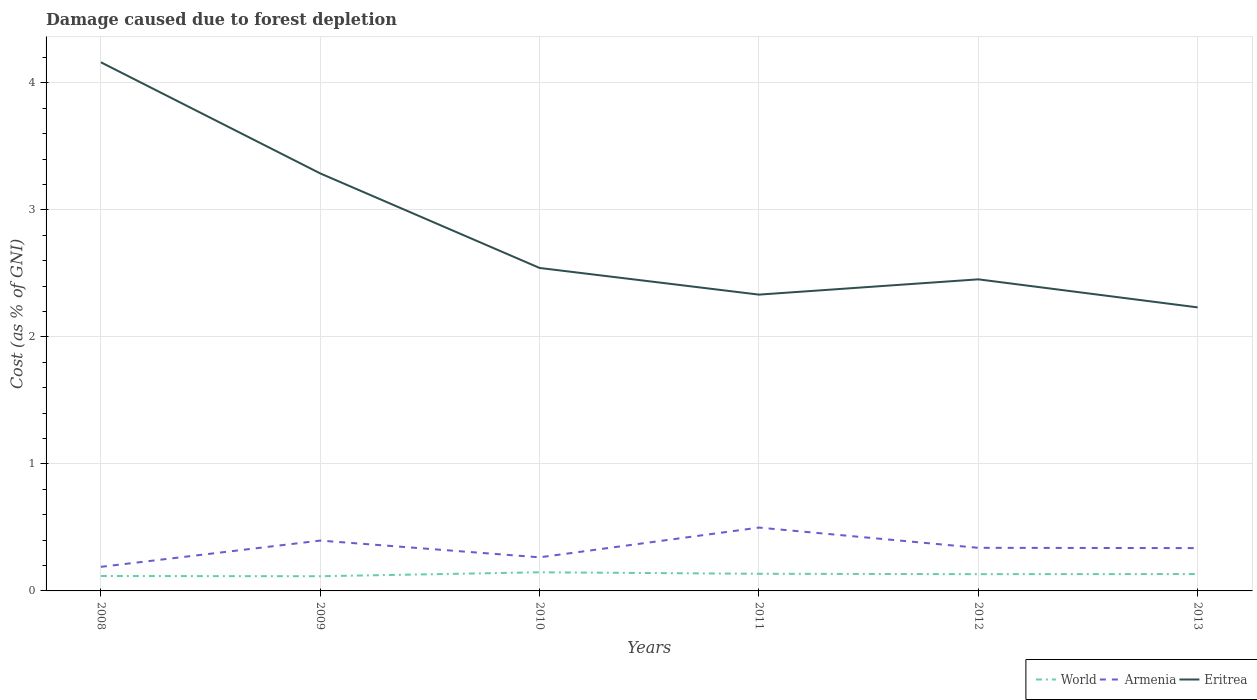How many different coloured lines are there?
Provide a succinct answer. 3. Is the number of lines equal to the number of legend labels?
Provide a short and direct response. Yes. Across all years, what is the maximum cost of damage caused due to forest depletion in World?
Keep it short and to the point. 0.12. What is the total cost of damage caused due to forest depletion in Eritrea in the graph?
Offer a very short reply. -0.12. What is the difference between the highest and the second highest cost of damage caused due to forest depletion in World?
Ensure brevity in your answer.  0.03. What is the difference between two consecutive major ticks on the Y-axis?
Provide a succinct answer. 1. Does the graph contain any zero values?
Ensure brevity in your answer.  No. Where does the legend appear in the graph?
Provide a succinct answer. Bottom right. How many legend labels are there?
Your response must be concise. 3. What is the title of the graph?
Keep it short and to the point. Damage caused due to forest depletion. Does "Greenland" appear as one of the legend labels in the graph?
Provide a succinct answer. No. What is the label or title of the Y-axis?
Keep it short and to the point. Cost (as % of GNI). What is the Cost (as % of GNI) of World in 2008?
Provide a short and direct response. 0.12. What is the Cost (as % of GNI) in Armenia in 2008?
Keep it short and to the point. 0.19. What is the Cost (as % of GNI) in Eritrea in 2008?
Keep it short and to the point. 4.16. What is the Cost (as % of GNI) in World in 2009?
Offer a terse response. 0.12. What is the Cost (as % of GNI) in Armenia in 2009?
Your answer should be compact. 0.4. What is the Cost (as % of GNI) in Eritrea in 2009?
Make the answer very short. 3.29. What is the Cost (as % of GNI) in World in 2010?
Provide a short and direct response. 0.15. What is the Cost (as % of GNI) in Armenia in 2010?
Your answer should be compact. 0.26. What is the Cost (as % of GNI) of Eritrea in 2010?
Make the answer very short. 2.54. What is the Cost (as % of GNI) of World in 2011?
Give a very brief answer. 0.13. What is the Cost (as % of GNI) of Armenia in 2011?
Provide a succinct answer. 0.5. What is the Cost (as % of GNI) of Eritrea in 2011?
Your response must be concise. 2.33. What is the Cost (as % of GNI) in World in 2012?
Offer a terse response. 0.13. What is the Cost (as % of GNI) in Armenia in 2012?
Offer a terse response. 0.34. What is the Cost (as % of GNI) of Eritrea in 2012?
Offer a very short reply. 2.45. What is the Cost (as % of GNI) in World in 2013?
Give a very brief answer. 0.13. What is the Cost (as % of GNI) of Armenia in 2013?
Give a very brief answer. 0.34. What is the Cost (as % of GNI) in Eritrea in 2013?
Ensure brevity in your answer.  2.23. Across all years, what is the maximum Cost (as % of GNI) of World?
Give a very brief answer. 0.15. Across all years, what is the maximum Cost (as % of GNI) in Armenia?
Provide a short and direct response. 0.5. Across all years, what is the maximum Cost (as % of GNI) in Eritrea?
Offer a very short reply. 4.16. Across all years, what is the minimum Cost (as % of GNI) in World?
Offer a terse response. 0.12. Across all years, what is the minimum Cost (as % of GNI) in Armenia?
Offer a very short reply. 0.19. Across all years, what is the minimum Cost (as % of GNI) in Eritrea?
Keep it short and to the point. 2.23. What is the total Cost (as % of GNI) in World in the graph?
Your response must be concise. 0.78. What is the total Cost (as % of GNI) of Armenia in the graph?
Make the answer very short. 2.03. What is the total Cost (as % of GNI) of Eritrea in the graph?
Offer a very short reply. 17.01. What is the difference between the Cost (as % of GNI) of World in 2008 and that in 2009?
Your answer should be compact. 0. What is the difference between the Cost (as % of GNI) of Armenia in 2008 and that in 2009?
Ensure brevity in your answer.  -0.21. What is the difference between the Cost (as % of GNI) of Eritrea in 2008 and that in 2009?
Make the answer very short. 0.87. What is the difference between the Cost (as % of GNI) of World in 2008 and that in 2010?
Your response must be concise. -0.03. What is the difference between the Cost (as % of GNI) of Armenia in 2008 and that in 2010?
Your answer should be very brief. -0.07. What is the difference between the Cost (as % of GNI) of Eritrea in 2008 and that in 2010?
Provide a short and direct response. 1.62. What is the difference between the Cost (as % of GNI) of World in 2008 and that in 2011?
Your answer should be very brief. -0.02. What is the difference between the Cost (as % of GNI) in Armenia in 2008 and that in 2011?
Your response must be concise. -0.31. What is the difference between the Cost (as % of GNI) in Eritrea in 2008 and that in 2011?
Provide a succinct answer. 1.83. What is the difference between the Cost (as % of GNI) in World in 2008 and that in 2012?
Give a very brief answer. -0.01. What is the difference between the Cost (as % of GNI) of Armenia in 2008 and that in 2012?
Offer a terse response. -0.15. What is the difference between the Cost (as % of GNI) of Eritrea in 2008 and that in 2012?
Offer a terse response. 1.71. What is the difference between the Cost (as % of GNI) of World in 2008 and that in 2013?
Your response must be concise. -0.02. What is the difference between the Cost (as % of GNI) in Armenia in 2008 and that in 2013?
Offer a terse response. -0.15. What is the difference between the Cost (as % of GNI) in Eritrea in 2008 and that in 2013?
Provide a short and direct response. 1.93. What is the difference between the Cost (as % of GNI) in World in 2009 and that in 2010?
Your answer should be compact. -0.03. What is the difference between the Cost (as % of GNI) in Armenia in 2009 and that in 2010?
Make the answer very short. 0.13. What is the difference between the Cost (as % of GNI) of Eritrea in 2009 and that in 2010?
Make the answer very short. 0.74. What is the difference between the Cost (as % of GNI) in World in 2009 and that in 2011?
Keep it short and to the point. -0.02. What is the difference between the Cost (as % of GNI) in Armenia in 2009 and that in 2011?
Provide a succinct answer. -0.1. What is the difference between the Cost (as % of GNI) of Eritrea in 2009 and that in 2011?
Make the answer very short. 0.95. What is the difference between the Cost (as % of GNI) of World in 2009 and that in 2012?
Give a very brief answer. -0.02. What is the difference between the Cost (as % of GNI) of Armenia in 2009 and that in 2012?
Ensure brevity in your answer.  0.06. What is the difference between the Cost (as % of GNI) in Eritrea in 2009 and that in 2012?
Your answer should be very brief. 0.83. What is the difference between the Cost (as % of GNI) of World in 2009 and that in 2013?
Your answer should be very brief. -0.02. What is the difference between the Cost (as % of GNI) in Armenia in 2009 and that in 2013?
Provide a short and direct response. 0.06. What is the difference between the Cost (as % of GNI) in Eritrea in 2009 and that in 2013?
Provide a short and direct response. 1.05. What is the difference between the Cost (as % of GNI) of World in 2010 and that in 2011?
Your answer should be compact. 0.01. What is the difference between the Cost (as % of GNI) in Armenia in 2010 and that in 2011?
Offer a terse response. -0.23. What is the difference between the Cost (as % of GNI) in Eritrea in 2010 and that in 2011?
Your response must be concise. 0.21. What is the difference between the Cost (as % of GNI) in World in 2010 and that in 2012?
Your response must be concise. 0.01. What is the difference between the Cost (as % of GNI) in Armenia in 2010 and that in 2012?
Make the answer very short. -0.07. What is the difference between the Cost (as % of GNI) of Eritrea in 2010 and that in 2012?
Make the answer very short. 0.09. What is the difference between the Cost (as % of GNI) of World in 2010 and that in 2013?
Give a very brief answer. 0.01. What is the difference between the Cost (as % of GNI) in Armenia in 2010 and that in 2013?
Provide a short and direct response. -0.07. What is the difference between the Cost (as % of GNI) of Eritrea in 2010 and that in 2013?
Offer a very short reply. 0.31. What is the difference between the Cost (as % of GNI) of World in 2011 and that in 2012?
Offer a very short reply. 0. What is the difference between the Cost (as % of GNI) in Armenia in 2011 and that in 2012?
Your response must be concise. 0.16. What is the difference between the Cost (as % of GNI) in Eritrea in 2011 and that in 2012?
Your answer should be very brief. -0.12. What is the difference between the Cost (as % of GNI) of World in 2011 and that in 2013?
Offer a terse response. 0. What is the difference between the Cost (as % of GNI) in Armenia in 2011 and that in 2013?
Offer a terse response. 0.16. What is the difference between the Cost (as % of GNI) of Eritrea in 2011 and that in 2013?
Provide a short and direct response. 0.1. What is the difference between the Cost (as % of GNI) in World in 2012 and that in 2013?
Your response must be concise. -0. What is the difference between the Cost (as % of GNI) in Armenia in 2012 and that in 2013?
Your response must be concise. 0. What is the difference between the Cost (as % of GNI) of Eritrea in 2012 and that in 2013?
Provide a short and direct response. 0.22. What is the difference between the Cost (as % of GNI) in World in 2008 and the Cost (as % of GNI) in Armenia in 2009?
Offer a terse response. -0.28. What is the difference between the Cost (as % of GNI) in World in 2008 and the Cost (as % of GNI) in Eritrea in 2009?
Make the answer very short. -3.17. What is the difference between the Cost (as % of GNI) in Armenia in 2008 and the Cost (as % of GNI) in Eritrea in 2009?
Give a very brief answer. -3.1. What is the difference between the Cost (as % of GNI) of World in 2008 and the Cost (as % of GNI) of Armenia in 2010?
Provide a short and direct response. -0.15. What is the difference between the Cost (as % of GNI) of World in 2008 and the Cost (as % of GNI) of Eritrea in 2010?
Keep it short and to the point. -2.43. What is the difference between the Cost (as % of GNI) in Armenia in 2008 and the Cost (as % of GNI) in Eritrea in 2010?
Keep it short and to the point. -2.35. What is the difference between the Cost (as % of GNI) in World in 2008 and the Cost (as % of GNI) in Armenia in 2011?
Offer a terse response. -0.38. What is the difference between the Cost (as % of GNI) of World in 2008 and the Cost (as % of GNI) of Eritrea in 2011?
Your answer should be very brief. -2.22. What is the difference between the Cost (as % of GNI) in Armenia in 2008 and the Cost (as % of GNI) in Eritrea in 2011?
Provide a succinct answer. -2.14. What is the difference between the Cost (as % of GNI) in World in 2008 and the Cost (as % of GNI) in Armenia in 2012?
Offer a very short reply. -0.22. What is the difference between the Cost (as % of GNI) in World in 2008 and the Cost (as % of GNI) in Eritrea in 2012?
Provide a succinct answer. -2.34. What is the difference between the Cost (as % of GNI) of Armenia in 2008 and the Cost (as % of GNI) of Eritrea in 2012?
Your answer should be compact. -2.26. What is the difference between the Cost (as % of GNI) in World in 2008 and the Cost (as % of GNI) in Armenia in 2013?
Make the answer very short. -0.22. What is the difference between the Cost (as % of GNI) of World in 2008 and the Cost (as % of GNI) of Eritrea in 2013?
Provide a short and direct response. -2.11. What is the difference between the Cost (as % of GNI) of Armenia in 2008 and the Cost (as % of GNI) of Eritrea in 2013?
Ensure brevity in your answer.  -2.04. What is the difference between the Cost (as % of GNI) of World in 2009 and the Cost (as % of GNI) of Armenia in 2010?
Offer a terse response. -0.15. What is the difference between the Cost (as % of GNI) of World in 2009 and the Cost (as % of GNI) of Eritrea in 2010?
Keep it short and to the point. -2.43. What is the difference between the Cost (as % of GNI) of Armenia in 2009 and the Cost (as % of GNI) of Eritrea in 2010?
Provide a succinct answer. -2.15. What is the difference between the Cost (as % of GNI) in World in 2009 and the Cost (as % of GNI) in Armenia in 2011?
Your answer should be compact. -0.38. What is the difference between the Cost (as % of GNI) of World in 2009 and the Cost (as % of GNI) of Eritrea in 2011?
Your response must be concise. -2.22. What is the difference between the Cost (as % of GNI) of Armenia in 2009 and the Cost (as % of GNI) of Eritrea in 2011?
Provide a short and direct response. -1.94. What is the difference between the Cost (as % of GNI) of World in 2009 and the Cost (as % of GNI) of Armenia in 2012?
Ensure brevity in your answer.  -0.22. What is the difference between the Cost (as % of GNI) in World in 2009 and the Cost (as % of GNI) in Eritrea in 2012?
Keep it short and to the point. -2.34. What is the difference between the Cost (as % of GNI) in Armenia in 2009 and the Cost (as % of GNI) in Eritrea in 2012?
Your answer should be compact. -2.06. What is the difference between the Cost (as % of GNI) in World in 2009 and the Cost (as % of GNI) in Armenia in 2013?
Give a very brief answer. -0.22. What is the difference between the Cost (as % of GNI) in World in 2009 and the Cost (as % of GNI) in Eritrea in 2013?
Keep it short and to the point. -2.12. What is the difference between the Cost (as % of GNI) of Armenia in 2009 and the Cost (as % of GNI) of Eritrea in 2013?
Offer a terse response. -1.84. What is the difference between the Cost (as % of GNI) of World in 2010 and the Cost (as % of GNI) of Armenia in 2011?
Provide a succinct answer. -0.35. What is the difference between the Cost (as % of GNI) of World in 2010 and the Cost (as % of GNI) of Eritrea in 2011?
Provide a succinct answer. -2.19. What is the difference between the Cost (as % of GNI) in Armenia in 2010 and the Cost (as % of GNI) in Eritrea in 2011?
Offer a very short reply. -2.07. What is the difference between the Cost (as % of GNI) in World in 2010 and the Cost (as % of GNI) in Armenia in 2012?
Provide a short and direct response. -0.19. What is the difference between the Cost (as % of GNI) of World in 2010 and the Cost (as % of GNI) of Eritrea in 2012?
Provide a short and direct response. -2.31. What is the difference between the Cost (as % of GNI) of Armenia in 2010 and the Cost (as % of GNI) of Eritrea in 2012?
Provide a short and direct response. -2.19. What is the difference between the Cost (as % of GNI) of World in 2010 and the Cost (as % of GNI) of Armenia in 2013?
Provide a succinct answer. -0.19. What is the difference between the Cost (as % of GNI) in World in 2010 and the Cost (as % of GNI) in Eritrea in 2013?
Ensure brevity in your answer.  -2.09. What is the difference between the Cost (as % of GNI) in Armenia in 2010 and the Cost (as % of GNI) in Eritrea in 2013?
Your answer should be compact. -1.97. What is the difference between the Cost (as % of GNI) in World in 2011 and the Cost (as % of GNI) in Armenia in 2012?
Make the answer very short. -0.2. What is the difference between the Cost (as % of GNI) of World in 2011 and the Cost (as % of GNI) of Eritrea in 2012?
Your answer should be compact. -2.32. What is the difference between the Cost (as % of GNI) in Armenia in 2011 and the Cost (as % of GNI) in Eritrea in 2012?
Your answer should be compact. -1.95. What is the difference between the Cost (as % of GNI) of World in 2011 and the Cost (as % of GNI) of Armenia in 2013?
Your answer should be compact. -0.2. What is the difference between the Cost (as % of GNI) of World in 2011 and the Cost (as % of GNI) of Eritrea in 2013?
Provide a short and direct response. -2.1. What is the difference between the Cost (as % of GNI) in Armenia in 2011 and the Cost (as % of GNI) in Eritrea in 2013?
Make the answer very short. -1.73. What is the difference between the Cost (as % of GNI) of World in 2012 and the Cost (as % of GNI) of Armenia in 2013?
Provide a succinct answer. -0.2. What is the difference between the Cost (as % of GNI) in World in 2012 and the Cost (as % of GNI) in Eritrea in 2013?
Make the answer very short. -2.1. What is the difference between the Cost (as % of GNI) in Armenia in 2012 and the Cost (as % of GNI) in Eritrea in 2013?
Make the answer very short. -1.89. What is the average Cost (as % of GNI) in World per year?
Your response must be concise. 0.13. What is the average Cost (as % of GNI) of Armenia per year?
Your answer should be compact. 0.34. What is the average Cost (as % of GNI) in Eritrea per year?
Provide a succinct answer. 2.83. In the year 2008, what is the difference between the Cost (as % of GNI) of World and Cost (as % of GNI) of Armenia?
Your response must be concise. -0.07. In the year 2008, what is the difference between the Cost (as % of GNI) in World and Cost (as % of GNI) in Eritrea?
Give a very brief answer. -4.04. In the year 2008, what is the difference between the Cost (as % of GNI) in Armenia and Cost (as % of GNI) in Eritrea?
Offer a very short reply. -3.97. In the year 2009, what is the difference between the Cost (as % of GNI) in World and Cost (as % of GNI) in Armenia?
Offer a very short reply. -0.28. In the year 2009, what is the difference between the Cost (as % of GNI) of World and Cost (as % of GNI) of Eritrea?
Keep it short and to the point. -3.17. In the year 2009, what is the difference between the Cost (as % of GNI) in Armenia and Cost (as % of GNI) in Eritrea?
Your response must be concise. -2.89. In the year 2010, what is the difference between the Cost (as % of GNI) in World and Cost (as % of GNI) in Armenia?
Offer a terse response. -0.12. In the year 2010, what is the difference between the Cost (as % of GNI) of World and Cost (as % of GNI) of Eritrea?
Your answer should be very brief. -2.4. In the year 2010, what is the difference between the Cost (as % of GNI) in Armenia and Cost (as % of GNI) in Eritrea?
Offer a terse response. -2.28. In the year 2011, what is the difference between the Cost (as % of GNI) of World and Cost (as % of GNI) of Armenia?
Your answer should be compact. -0.36. In the year 2011, what is the difference between the Cost (as % of GNI) of World and Cost (as % of GNI) of Eritrea?
Provide a short and direct response. -2.2. In the year 2011, what is the difference between the Cost (as % of GNI) in Armenia and Cost (as % of GNI) in Eritrea?
Provide a short and direct response. -1.83. In the year 2012, what is the difference between the Cost (as % of GNI) of World and Cost (as % of GNI) of Armenia?
Your answer should be very brief. -0.21. In the year 2012, what is the difference between the Cost (as % of GNI) of World and Cost (as % of GNI) of Eritrea?
Offer a terse response. -2.32. In the year 2012, what is the difference between the Cost (as % of GNI) in Armenia and Cost (as % of GNI) in Eritrea?
Give a very brief answer. -2.11. In the year 2013, what is the difference between the Cost (as % of GNI) in World and Cost (as % of GNI) in Armenia?
Your answer should be very brief. -0.2. In the year 2013, what is the difference between the Cost (as % of GNI) of World and Cost (as % of GNI) of Eritrea?
Keep it short and to the point. -2.1. In the year 2013, what is the difference between the Cost (as % of GNI) in Armenia and Cost (as % of GNI) in Eritrea?
Your answer should be compact. -1.9. What is the ratio of the Cost (as % of GNI) of Armenia in 2008 to that in 2009?
Your answer should be compact. 0.48. What is the ratio of the Cost (as % of GNI) of Eritrea in 2008 to that in 2009?
Provide a short and direct response. 1.27. What is the ratio of the Cost (as % of GNI) of World in 2008 to that in 2010?
Offer a terse response. 0.8. What is the ratio of the Cost (as % of GNI) of Armenia in 2008 to that in 2010?
Provide a succinct answer. 0.72. What is the ratio of the Cost (as % of GNI) of Eritrea in 2008 to that in 2010?
Keep it short and to the point. 1.64. What is the ratio of the Cost (as % of GNI) of World in 2008 to that in 2011?
Provide a short and direct response. 0.87. What is the ratio of the Cost (as % of GNI) of Armenia in 2008 to that in 2011?
Make the answer very short. 0.38. What is the ratio of the Cost (as % of GNI) in Eritrea in 2008 to that in 2011?
Your answer should be very brief. 1.78. What is the ratio of the Cost (as % of GNI) in World in 2008 to that in 2012?
Provide a short and direct response. 0.89. What is the ratio of the Cost (as % of GNI) of Armenia in 2008 to that in 2012?
Your answer should be very brief. 0.56. What is the ratio of the Cost (as % of GNI) in Eritrea in 2008 to that in 2012?
Provide a succinct answer. 1.7. What is the ratio of the Cost (as % of GNI) in World in 2008 to that in 2013?
Offer a very short reply. 0.88. What is the ratio of the Cost (as % of GNI) in Armenia in 2008 to that in 2013?
Provide a succinct answer. 0.56. What is the ratio of the Cost (as % of GNI) of Eritrea in 2008 to that in 2013?
Your answer should be very brief. 1.86. What is the ratio of the Cost (as % of GNI) of World in 2009 to that in 2010?
Give a very brief answer. 0.79. What is the ratio of the Cost (as % of GNI) of Armenia in 2009 to that in 2010?
Your answer should be very brief. 1.5. What is the ratio of the Cost (as % of GNI) of Eritrea in 2009 to that in 2010?
Give a very brief answer. 1.29. What is the ratio of the Cost (as % of GNI) of World in 2009 to that in 2011?
Your response must be concise. 0.86. What is the ratio of the Cost (as % of GNI) in Armenia in 2009 to that in 2011?
Keep it short and to the point. 0.79. What is the ratio of the Cost (as % of GNI) of Eritrea in 2009 to that in 2011?
Your answer should be very brief. 1.41. What is the ratio of the Cost (as % of GNI) of World in 2009 to that in 2012?
Keep it short and to the point. 0.87. What is the ratio of the Cost (as % of GNI) in Armenia in 2009 to that in 2012?
Make the answer very short. 1.17. What is the ratio of the Cost (as % of GNI) of Eritrea in 2009 to that in 2012?
Give a very brief answer. 1.34. What is the ratio of the Cost (as % of GNI) in World in 2009 to that in 2013?
Offer a very short reply. 0.87. What is the ratio of the Cost (as % of GNI) in Armenia in 2009 to that in 2013?
Keep it short and to the point. 1.18. What is the ratio of the Cost (as % of GNI) in Eritrea in 2009 to that in 2013?
Offer a very short reply. 1.47. What is the ratio of the Cost (as % of GNI) of World in 2010 to that in 2011?
Make the answer very short. 1.09. What is the ratio of the Cost (as % of GNI) of Armenia in 2010 to that in 2011?
Provide a succinct answer. 0.53. What is the ratio of the Cost (as % of GNI) in Eritrea in 2010 to that in 2011?
Provide a succinct answer. 1.09. What is the ratio of the Cost (as % of GNI) of World in 2010 to that in 2012?
Offer a very short reply. 1.11. What is the ratio of the Cost (as % of GNI) in Armenia in 2010 to that in 2012?
Your answer should be very brief. 0.78. What is the ratio of the Cost (as % of GNI) in Eritrea in 2010 to that in 2012?
Ensure brevity in your answer.  1.04. What is the ratio of the Cost (as % of GNI) in World in 2010 to that in 2013?
Make the answer very short. 1.1. What is the ratio of the Cost (as % of GNI) in Armenia in 2010 to that in 2013?
Offer a very short reply. 0.78. What is the ratio of the Cost (as % of GNI) in Eritrea in 2010 to that in 2013?
Provide a succinct answer. 1.14. What is the ratio of the Cost (as % of GNI) of World in 2011 to that in 2012?
Ensure brevity in your answer.  1.02. What is the ratio of the Cost (as % of GNI) in Armenia in 2011 to that in 2012?
Provide a short and direct response. 1.47. What is the ratio of the Cost (as % of GNI) of Eritrea in 2011 to that in 2012?
Provide a short and direct response. 0.95. What is the ratio of the Cost (as % of GNI) in World in 2011 to that in 2013?
Make the answer very short. 1.01. What is the ratio of the Cost (as % of GNI) in Armenia in 2011 to that in 2013?
Give a very brief answer. 1.48. What is the ratio of the Cost (as % of GNI) in Eritrea in 2011 to that in 2013?
Offer a very short reply. 1.04. What is the ratio of the Cost (as % of GNI) of World in 2012 to that in 2013?
Keep it short and to the point. 0.99. What is the ratio of the Cost (as % of GNI) of Eritrea in 2012 to that in 2013?
Make the answer very short. 1.1. What is the difference between the highest and the second highest Cost (as % of GNI) of World?
Your answer should be compact. 0.01. What is the difference between the highest and the second highest Cost (as % of GNI) of Armenia?
Your answer should be very brief. 0.1. What is the difference between the highest and the second highest Cost (as % of GNI) of Eritrea?
Your response must be concise. 0.87. What is the difference between the highest and the lowest Cost (as % of GNI) of World?
Offer a very short reply. 0.03. What is the difference between the highest and the lowest Cost (as % of GNI) of Armenia?
Your answer should be very brief. 0.31. What is the difference between the highest and the lowest Cost (as % of GNI) in Eritrea?
Your response must be concise. 1.93. 